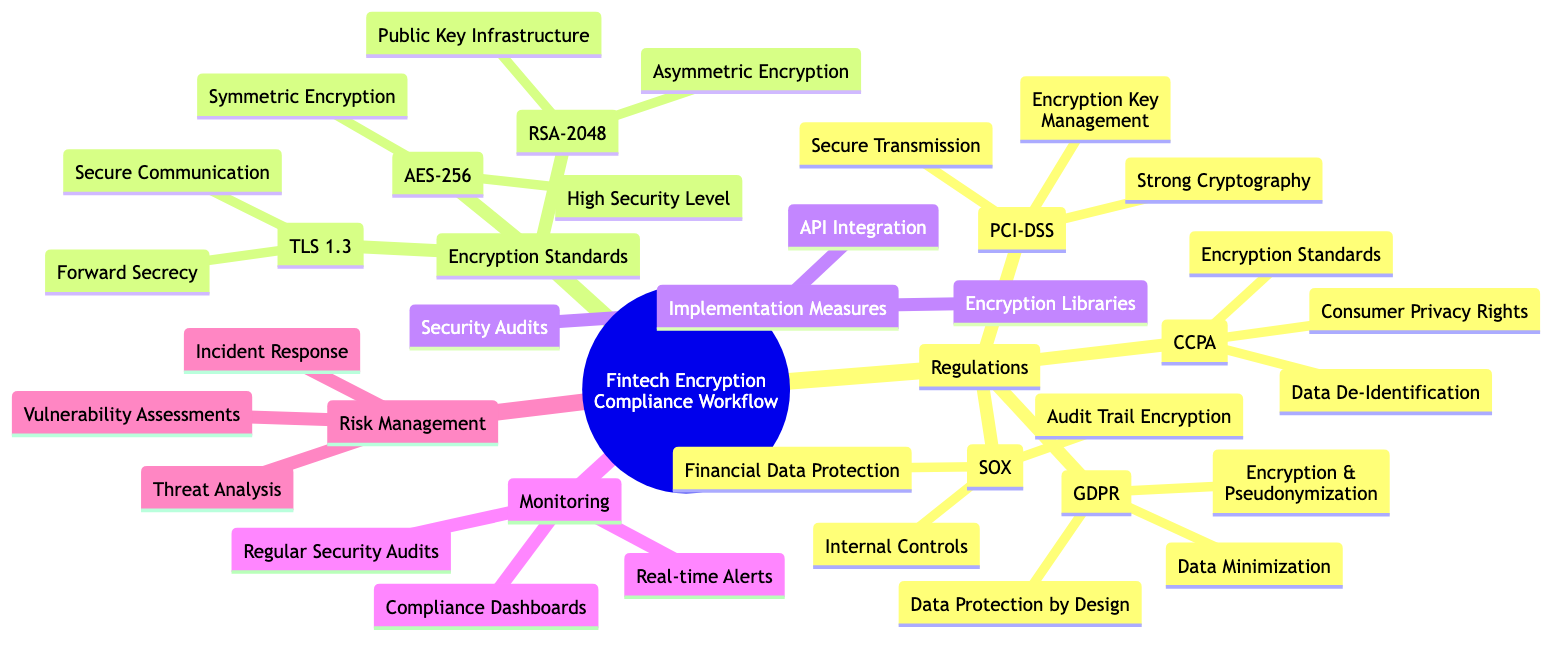What are the four main categories in the fintech encryption compliance workflow? The diagram consists of five main categories: Regulations, Encryption Standards, Implementation Measures, Monitoring, and Risk Management.
Answer: Regulations, Encryption Standards, Implementation Measures, Monitoring, Risk Management How many encryption standards are listed in the diagram? The diagram lists three encryption standards: AES-256, RSA-2048, and TLS 1.3.
Answer: Three What regulation focuses on data protection by design? GDPR, which stands for General Data Protection Regulation, contains the principle of Data Protection by Design as one of its components.
Answer: GDPR Which encryption standard is associated with asymmetric encryption? RSA-2048 is the encryption standard listed under the category of asymmetric encryption in the diagram.
Answer: RSA-2048 What components fall under PCI-DSS? PCI-DSS includes the components: Encryption Key Management, Strong Cryptography, and Secure Transmission.
Answer: Encryption Key Management, Strong Cryptography, Secure Transmission Which two standards are focused on compliance after implementation? The standards that are focused on compliance after implementation are Real-time Alerts and Regular Security Audits, both listed under Monitoring.
Answer: Real-time Alerts, Regular Security Audits How many measures are specified for implementation in the diagram? There are three implementation measures specified in the diagram: Encryption Libraries, API Integration, and Security Audits.
Answer: Three What does CCPA stand for? CCPA stands for California Consumer Privacy Act. It is a regulation mentioned in the diagram.
Answer: California Consumer Privacy Act Which regulation emphasizes consumer privacy rights? The regulation that emphasizes consumer privacy rights is the CCPA.
Answer: CCPA 